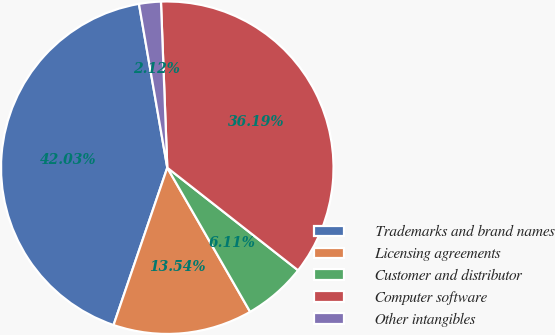Convert chart to OTSL. <chart><loc_0><loc_0><loc_500><loc_500><pie_chart><fcel>Trademarks and brand names<fcel>Licensing agreements<fcel>Customer and distributor<fcel>Computer software<fcel>Other intangibles<nl><fcel>42.03%<fcel>13.54%<fcel>6.11%<fcel>36.19%<fcel>2.12%<nl></chart> 